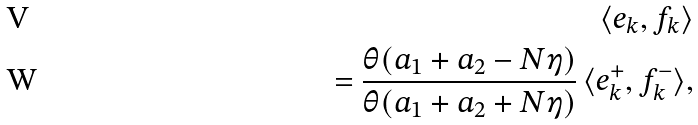Convert formula to latex. <formula><loc_0><loc_0><loc_500><loc_500>\langle e _ { k } , f _ { k } \rangle \\ = \frac { \theta ( a _ { 1 } + a _ { 2 } - N \eta ) } { \theta ( a _ { 1 } + a _ { 2 } + N \eta ) } \, \langle e _ { k } ^ { + } , f _ { k } ^ { - } \rangle ,</formula> 